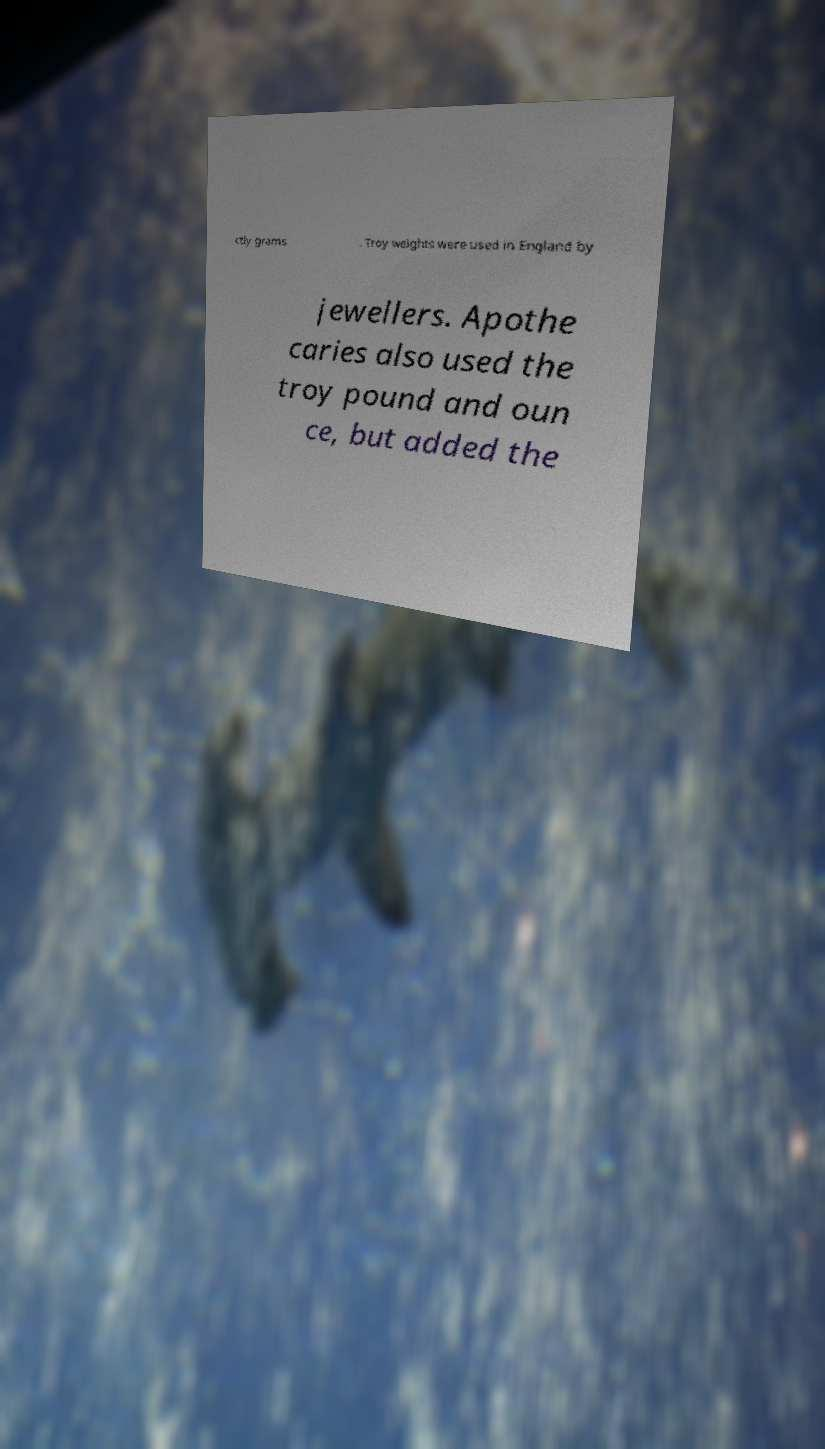Could you extract and type out the text from this image? ctly grams . Troy weights were used in England by jewellers. Apothe caries also used the troy pound and oun ce, but added the 